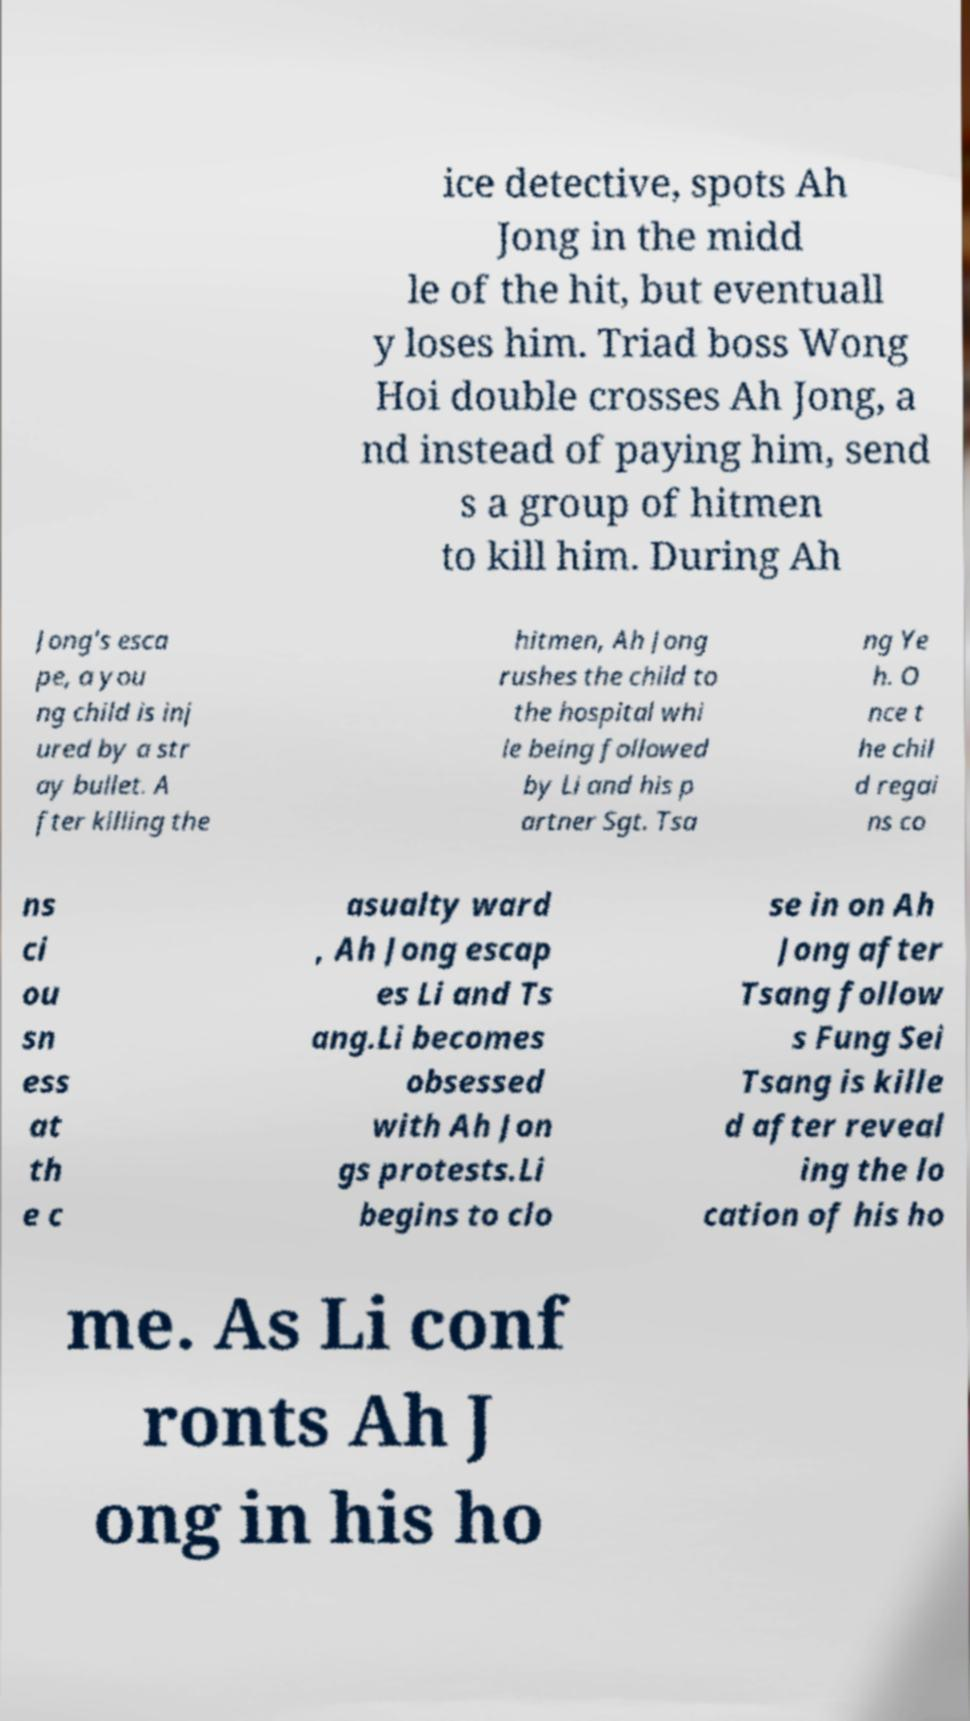I need the written content from this picture converted into text. Can you do that? ice detective, spots Ah Jong in the midd le of the hit, but eventuall y loses him. Triad boss Wong Hoi double crosses Ah Jong, a nd instead of paying him, send s a group of hitmen to kill him. During Ah Jong's esca pe, a you ng child is inj ured by a str ay bullet. A fter killing the hitmen, Ah Jong rushes the child to the hospital whi le being followed by Li and his p artner Sgt. Tsa ng Ye h. O nce t he chil d regai ns co ns ci ou sn ess at th e c asualty ward , Ah Jong escap es Li and Ts ang.Li becomes obsessed with Ah Jon gs protests.Li begins to clo se in on Ah Jong after Tsang follow s Fung Sei Tsang is kille d after reveal ing the lo cation of his ho me. As Li conf ronts Ah J ong in his ho 